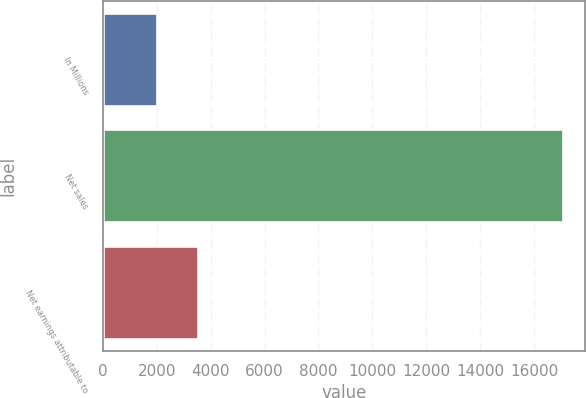Convert chart to OTSL. <chart><loc_0><loc_0><loc_500><loc_500><bar_chart><fcel>In Millions<fcel>Net sales<fcel>Net earnings attributable to<nl><fcel>2018<fcel>17057.4<fcel>3521.94<nl></chart> 